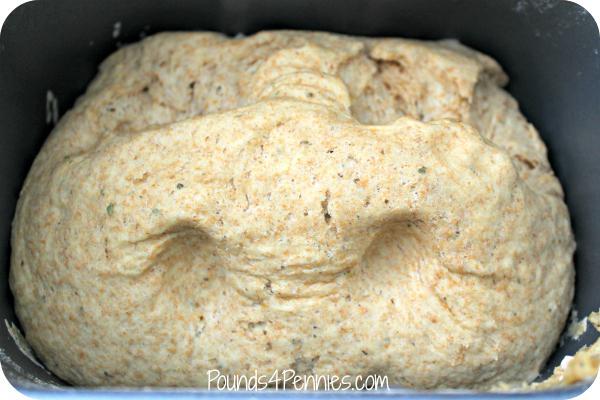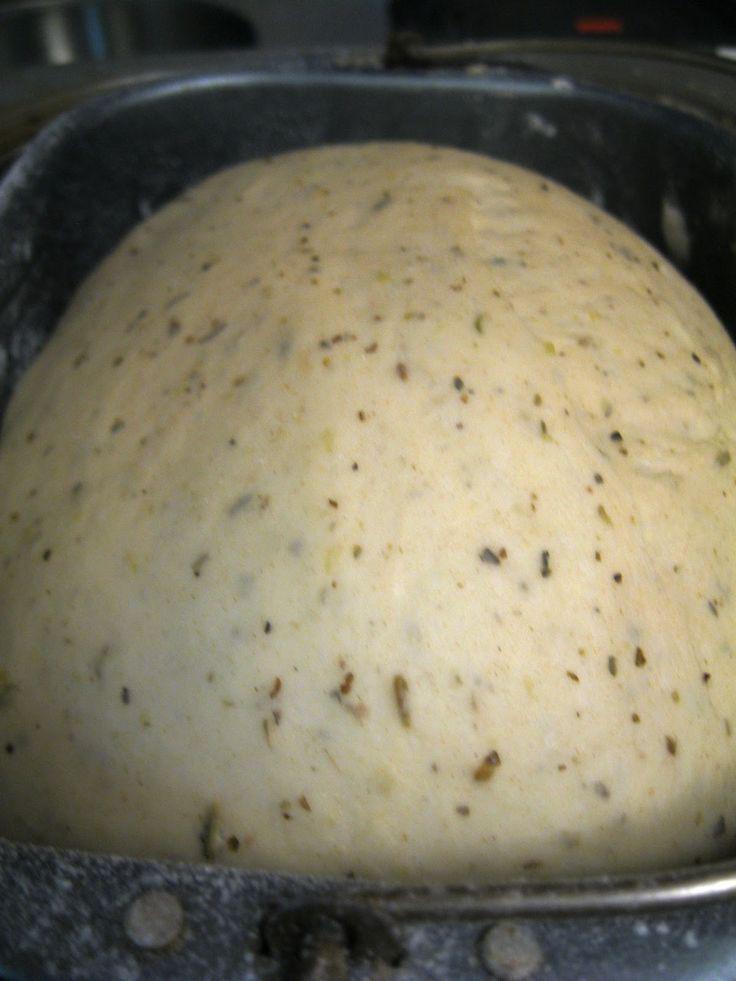The first image is the image on the left, the second image is the image on the right. For the images shown, is this caption "At least one image has a large ball of dough in a bowl-like container, and not directly on a flat surface." true? Answer yes or no. Yes. 